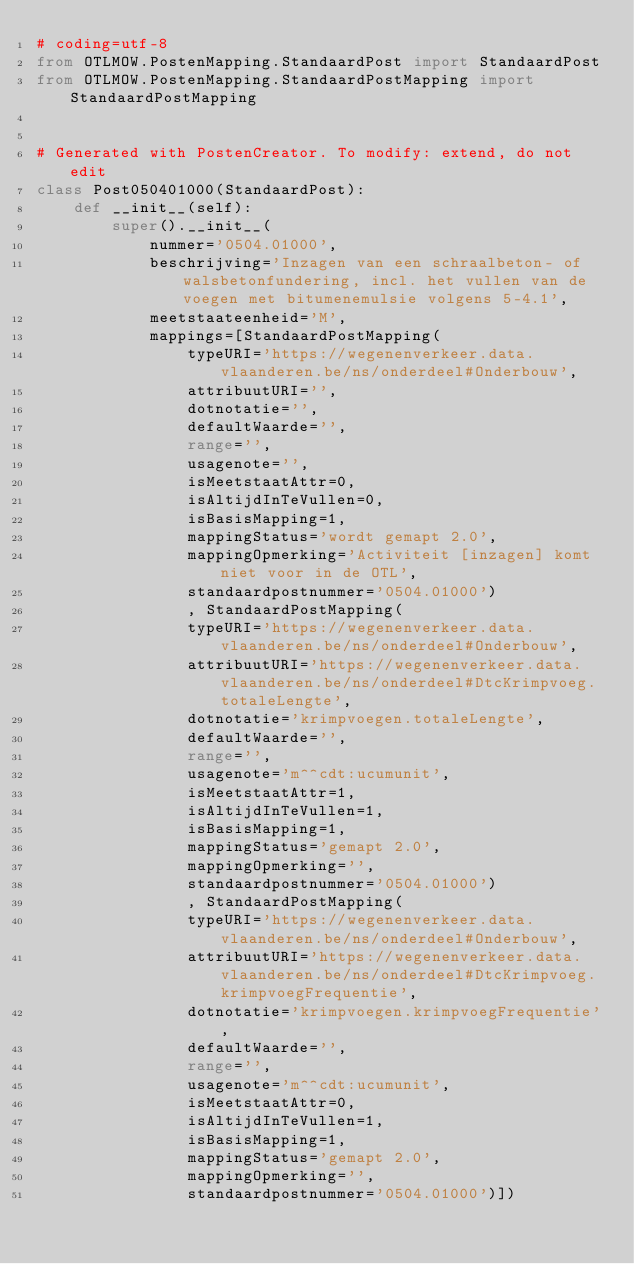Convert code to text. <code><loc_0><loc_0><loc_500><loc_500><_Python_># coding=utf-8
from OTLMOW.PostenMapping.StandaardPost import StandaardPost
from OTLMOW.PostenMapping.StandaardPostMapping import StandaardPostMapping


# Generated with PostenCreator. To modify: extend, do not edit
class Post050401000(StandaardPost):
    def __init__(self):
        super().__init__(
            nummer='0504.01000',
            beschrijving='Inzagen van een schraalbeton- of walsbetonfundering, incl. het vullen van de voegen met bitumenemulsie volgens 5-4.1',
            meetstaateenheid='M',
            mappings=[StandaardPostMapping(
                typeURI='https://wegenenverkeer.data.vlaanderen.be/ns/onderdeel#Onderbouw',
                attribuutURI='',
                dotnotatie='',
                defaultWaarde='',
                range='',
                usagenote='',
                isMeetstaatAttr=0,
                isAltijdInTeVullen=0,
                isBasisMapping=1,
                mappingStatus='wordt gemapt 2.0',
                mappingOpmerking='Activiteit [inzagen] komt niet voor in de OTL',
                standaardpostnummer='0504.01000')
                , StandaardPostMapping(
                typeURI='https://wegenenverkeer.data.vlaanderen.be/ns/onderdeel#Onderbouw',
                attribuutURI='https://wegenenverkeer.data.vlaanderen.be/ns/onderdeel#DtcKrimpvoeg.totaleLengte',
                dotnotatie='krimpvoegen.totaleLengte',
                defaultWaarde='',
                range='',
                usagenote='m^^cdt:ucumunit',
                isMeetstaatAttr=1,
                isAltijdInTeVullen=1,
                isBasisMapping=1,
                mappingStatus='gemapt 2.0',
                mappingOpmerking='',
                standaardpostnummer='0504.01000')
                , StandaardPostMapping(
                typeURI='https://wegenenverkeer.data.vlaanderen.be/ns/onderdeel#Onderbouw',
                attribuutURI='https://wegenenverkeer.data.vlaanderen.be/ns/onderdeel#DtcKrimpvoeg.krimpvoegFrequentie',
                dotnotatie='krimpvoegen.krimpvoegFrequentie',
                defaultWaarde='',
                range='',
                usagenote='m^^cdt:ucumunit',
                isMeetstaatAttr=0,
                isAltijdInTeVullen=1,
                isBasisMapping=1,
                mappingStatus='gemapt 2.0',
                mappingOpmerking='',
                standaardpostnummer='0504.01000')])
</code> 